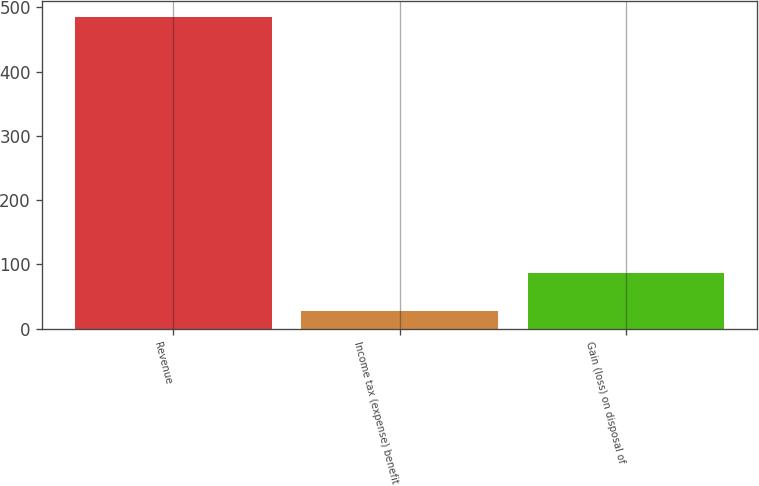Convert chart to OTSL. <chart><loc_0><loc_0><loc_500><loc_500><bar_chart><fcel>Revenue<fcel>Income tax (expense) benefit<fcel>Gain (loss) on disposal of<nl><fcel>485<fcel>27<fcel>86<nl></chart> 